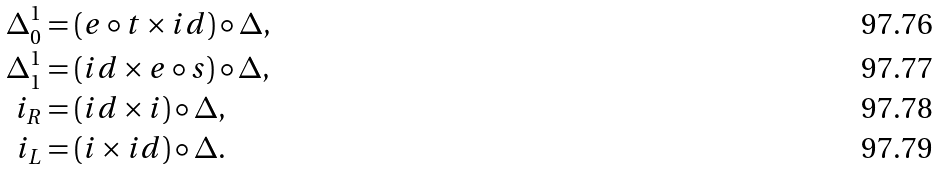<formula> <loc_0><loc_0><loc_500><loc_500>\Delta _ { 0 } ^ { 1 } & = ( e \circ t \times i d ) \circ \Delta , \\ \Delta _ { 1 } ^ { 1 } & = ( i d \times e \circ s ) \circ \Delta , \\ i _ { R } & = ( i d \times i ) \circ \Delta , \\ i _ { L } & = ( i \times i d ) \circ \Delta .</formula> 